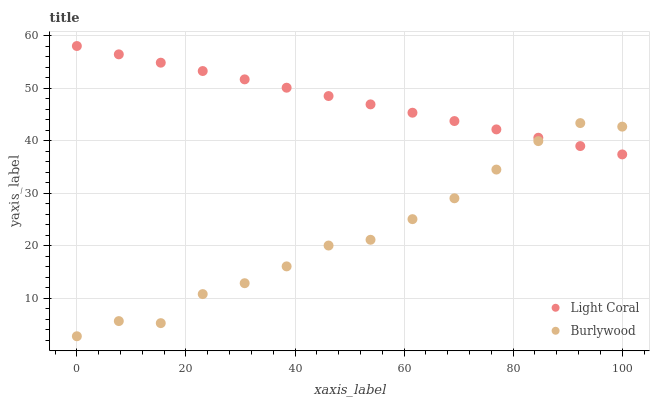Does Burlywood have the minimum area under the curve?
Answer yes or no. Yes. Does Light Coral have the maximum area under the curve?
Answer yes or no. Yes. Does Burlywood have the maximum area under the curve?
Answer yes or no. No. Is Light Coral the smoothest?
Answer yes or no. Yes. Is Burlywood the roughest?
Answer yes or no. Yes. Is Burlywood the smoothest?
Answer yes or no. No. Does Burlywood have the lowest value?
Answer yes or no. Yes. Does Light Coral have the highest value?
Answer yes or no. Yes. Does Burlywood have the highest value?
Answer yes or no. No. Does Burlywood intersect Light Coral?
Answer yes or no. Yes. Is Burlywood less than Light Coral?
Answer yes or no. No. Is Burlywood greater than Light Coral?
Answer yes or no. No. 